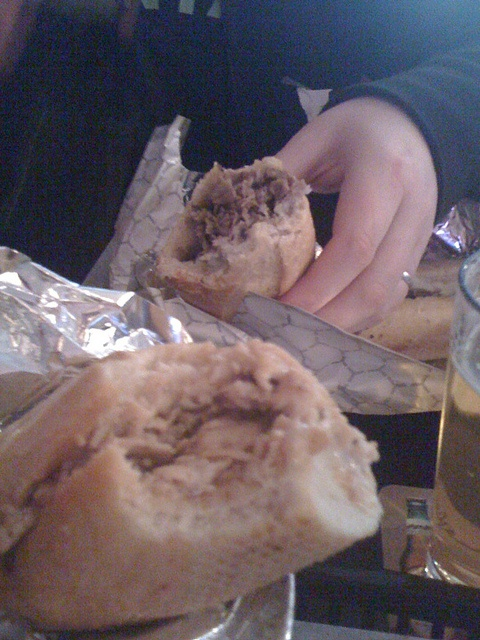Describe the objects in this image and their specific colors. I can see people in purple, black, navy, darkgray, and blue tones, sandwich in purple, gray, and darkgray tones, sandwich in purple, brown, gray, and darkgray tones, and cup in purple, gray, and maroon tones in this image. 